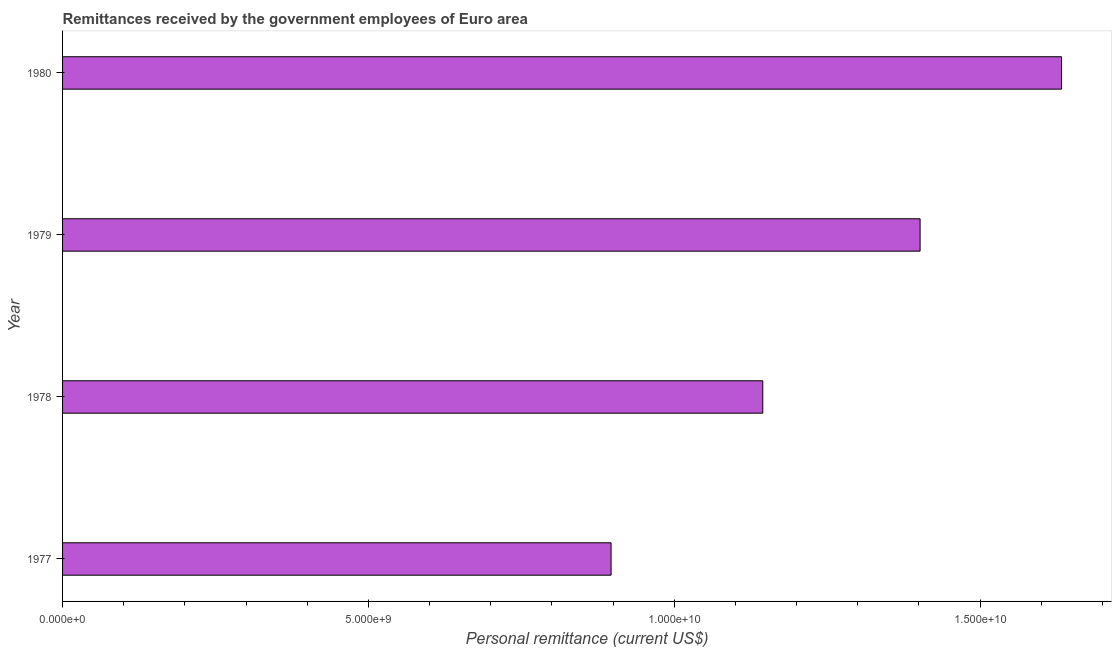Does the graph contain grids?
Offer a terse response. No. What is the title of the graph?
Ensure brevity in your answer.  Remittances received by the government employees of Euro area. What is the label or title of the X-axis?
Make the answer very short. Personal remittance (current US$). What is the personal remittances in 1977?
Your answer should be compact. 8.97e+09. Across all years, what is the maximum personal remittances?
Offer a very short reply. 1.63e+1. Across all years, what is the minimum personal remittances?
Make the answer very short. 8.97e+09. In which year was the personal remittances maximum?
Your answer should be very brief. 1980. What is the sum of the personal remittances?
Your answer should be very brief. 5.08e+1. What is the difference between the personal remittances in 1977 and 1978?
Provide a succinct answer. -2.48e+09. What is the average personal remittances per year?
Give a very brief answer. 1.27e+1. What is the median personal remittances?
Your answer should be compact. 1.27e+1. In how many years, is the personal remittances greater than 7000000000 US$?
Provide a succinct answer. 4. Do a majority of the years between 1977 and 1980 (inclusive) have personal remittances greater than 4000000000 US$?
Keep it short and to the point. Yes. What is the ratio of the personal remittances in 1977 to that in 1979?
Offer a very short reply. 0.64. Is the personal remittances in 1977 less than that in 1978?
Your response must be concise. Yes. Is the difference between the personal remittances in 1979 and 1980 greater than the difference between any two years?
Your answer should be compact. No. What is the difference between the highest and the second highest personal remittances?
Give a very brief answer. 2.31e+09. Is the sum of the personal remittances in 1979 and 1980 greater than the maximum personal remittances across all years?
Your answer should be very brief. Yes. What is the difference between the highest and the lowest personal remittances?
Offer a very short reply. 7.37e+09. In how many years, is the personal remittances greater than the average personal remittances taken over all years?
Offer a terse response. 2. How many bars are there?
Make the answer very short. 4. What is the difference between two consecutive major ticks on the X-axis?
Ensure brevity in your answer.  5.00e+09. What is the Personal remittance (current US$) of 1977?
Your answer should be very brief. 8.97e+09. What is the Personal remittance (current US$) of 1978?
Offer a terse response. 1.14e+1. What is the Personal remittance (current US$) of 1979?
Provide a short and direct response. 1.40e+1. What is the Personal remittance (current US$) of 1980?
Your response must be concise. 1.63e+1. What is the difference between the Personal remittance (current US$) in 1977 and 1978?
Your answer should be very brief. -2.48e+09. What is the difference between the Personal remittance (current US$) in 1977 and 1979?
Make the answer very short. -5.05e+09. What is the difference between the Personal remittance (current US$) in 1977 and 1980?
Your response must be concise. -7.37e+09. What is the difference between the Personal remittance (current US$) in 1978 and 1979?
Your answer should be compact. -2.57e+09. What is the difference between the Personal remittance (current US$) in 1978 and 1980?
Keep it short and to the point. -4.88e+09. What is the difference between the Personal remittance (current US$) in 1979 and 1980?
Make the answer very short. -2.31e+09. What is the ratio of the Personal remittance (current US$) in 1977 to that in 1978?
Make the answer very short. 0.78. What is the ratio of the Personal remittance (current US$) in 1977 to that in 1979?
Keep it short and to the point. 0.64. What is the ratio of the Personal remittance (current US$) in 1977 to that in 1980?
Ensure brevity in your answer.  0.55. What is the ratio of the Personal remittance (current US$) in 1978 to that in 1979?
Give a very brief answer. 0.82. What is the ratio of the Personal remittance (current US$) in 1978 to that in 1980?
Your response must be concise. 0.7. What is the ratio of the Personal remittance (current US$) in 1979 to that in 1980?
Provide a succinct answer. 0.86. 